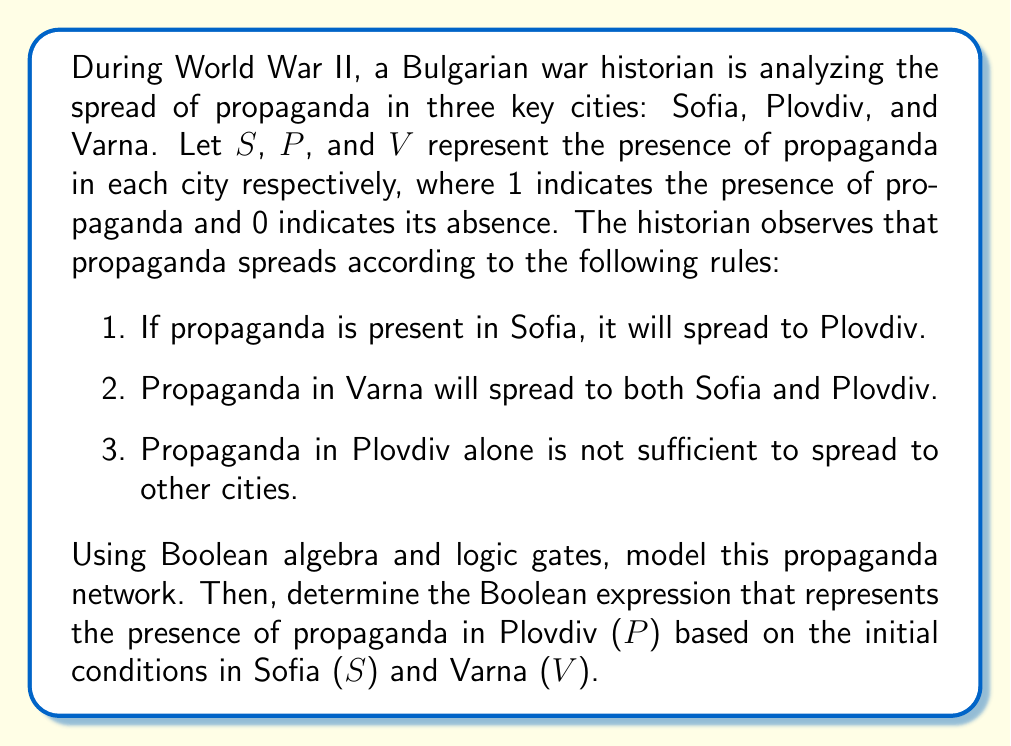Could you help me with this problem? Let's approach this problem step by step:

1. First, we need to model the rules using logic gates:

   Rule 1: $S \rightarrow P$ (OR gate)
   Rule 2: $V \rightarrow S$ and $V \rightarrow P$ (OR gates)
   Rule 3: $P$ alone doesn't affect $S$ or $V$

2. We can represent this system using the following logic circuit:

   [asy]
   import geometry;

   pen textpen = fontsize(10pt);

   void drawOR(pair center) {
     path p = (0,-20)--(0,20)--arc((0,0),20,90,-90)--cycle;
     draw(shift(center)*p);
   }

   draw((0,0)--(50,20), arrow=Arrow());
   draw((0,40)--(50,40), arrow=Arrow());
   draw((0,80)--(50,60), arrow=Arrow());

   drawOR((70,40));

   draw((90,40)--(140,40), arrow=Arrow());

   label("$S$", (0,0), W, textpen);
   label("$V$", (0,80), W, textpen);
   label("$P$", (140,40), E, textpen);
   [/asy]

3. From this circuit, we can derive the Boolean expression for $P$:

   $P = S + V$

   Where '+' represents the OR operation.

4. This expression means that propaganda will be present in Plovdiv if it's present in Sofia OR Varna (or both).

5. We can verify this expression against the given rules:
   - If $S = 1$, then $P = 1$ (satisfies rule 1)
   - If $V = 1$, then $P = 1$ (satisfies rule 2)
   - If $S = 0$ and $V = 0$, then $P = 0$ (satisfies rule 3)

Therefore, the Boolean expression $P = S + V$ accurately models the spread of propaganda to Plovdiv based on the initial conditions in Sofia and Varna.
Answer: $P = S + V$ 